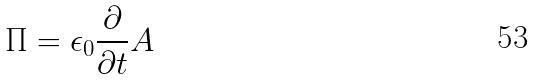<formula> <loc_0><loc_0><loc_500><loc_500>\Pi = \epsilon _ { 0 } \frac { \partial } { \partial t } A</formula> 